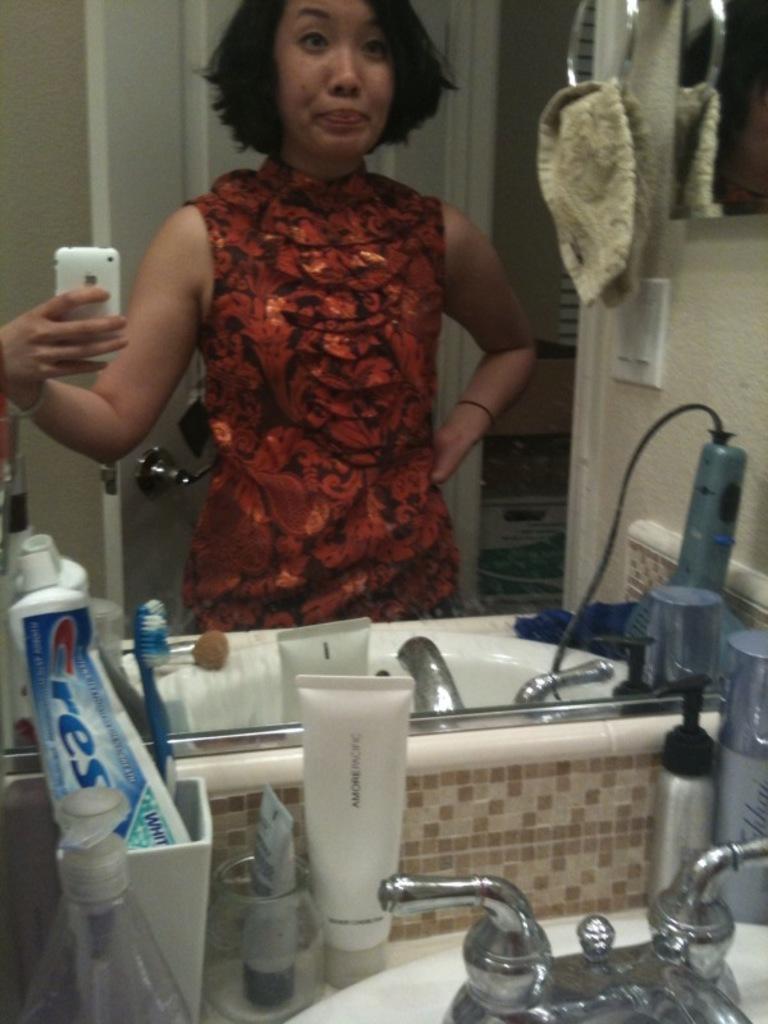What brand of toothpaste does she use?
Give a very brief answer. Crest. 